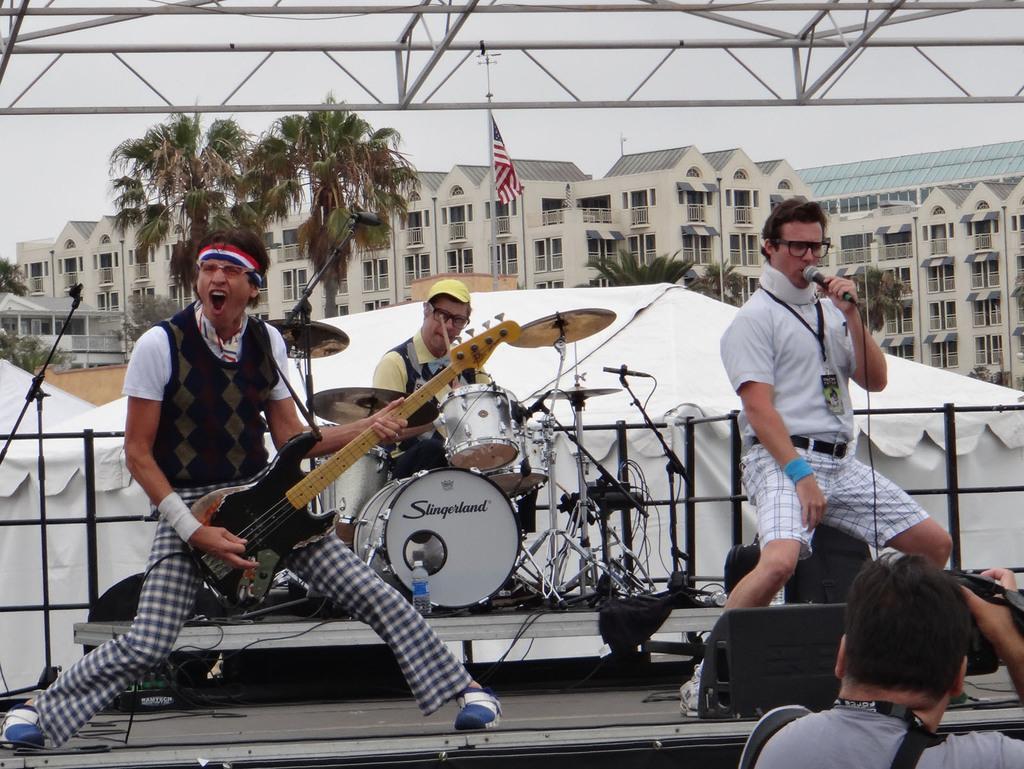Could you give a brief overview of what you see in this image? On the background we can see sky, huge buildings, trees. This is a flag. Here we can see a man holding a mike in his hand and singing. This man is holding a guitar in his hand and playing and singing. We can see this man playing drums here. Beside to them there is a tent in white colour. In Front portion of the picture we can see one man recording. 